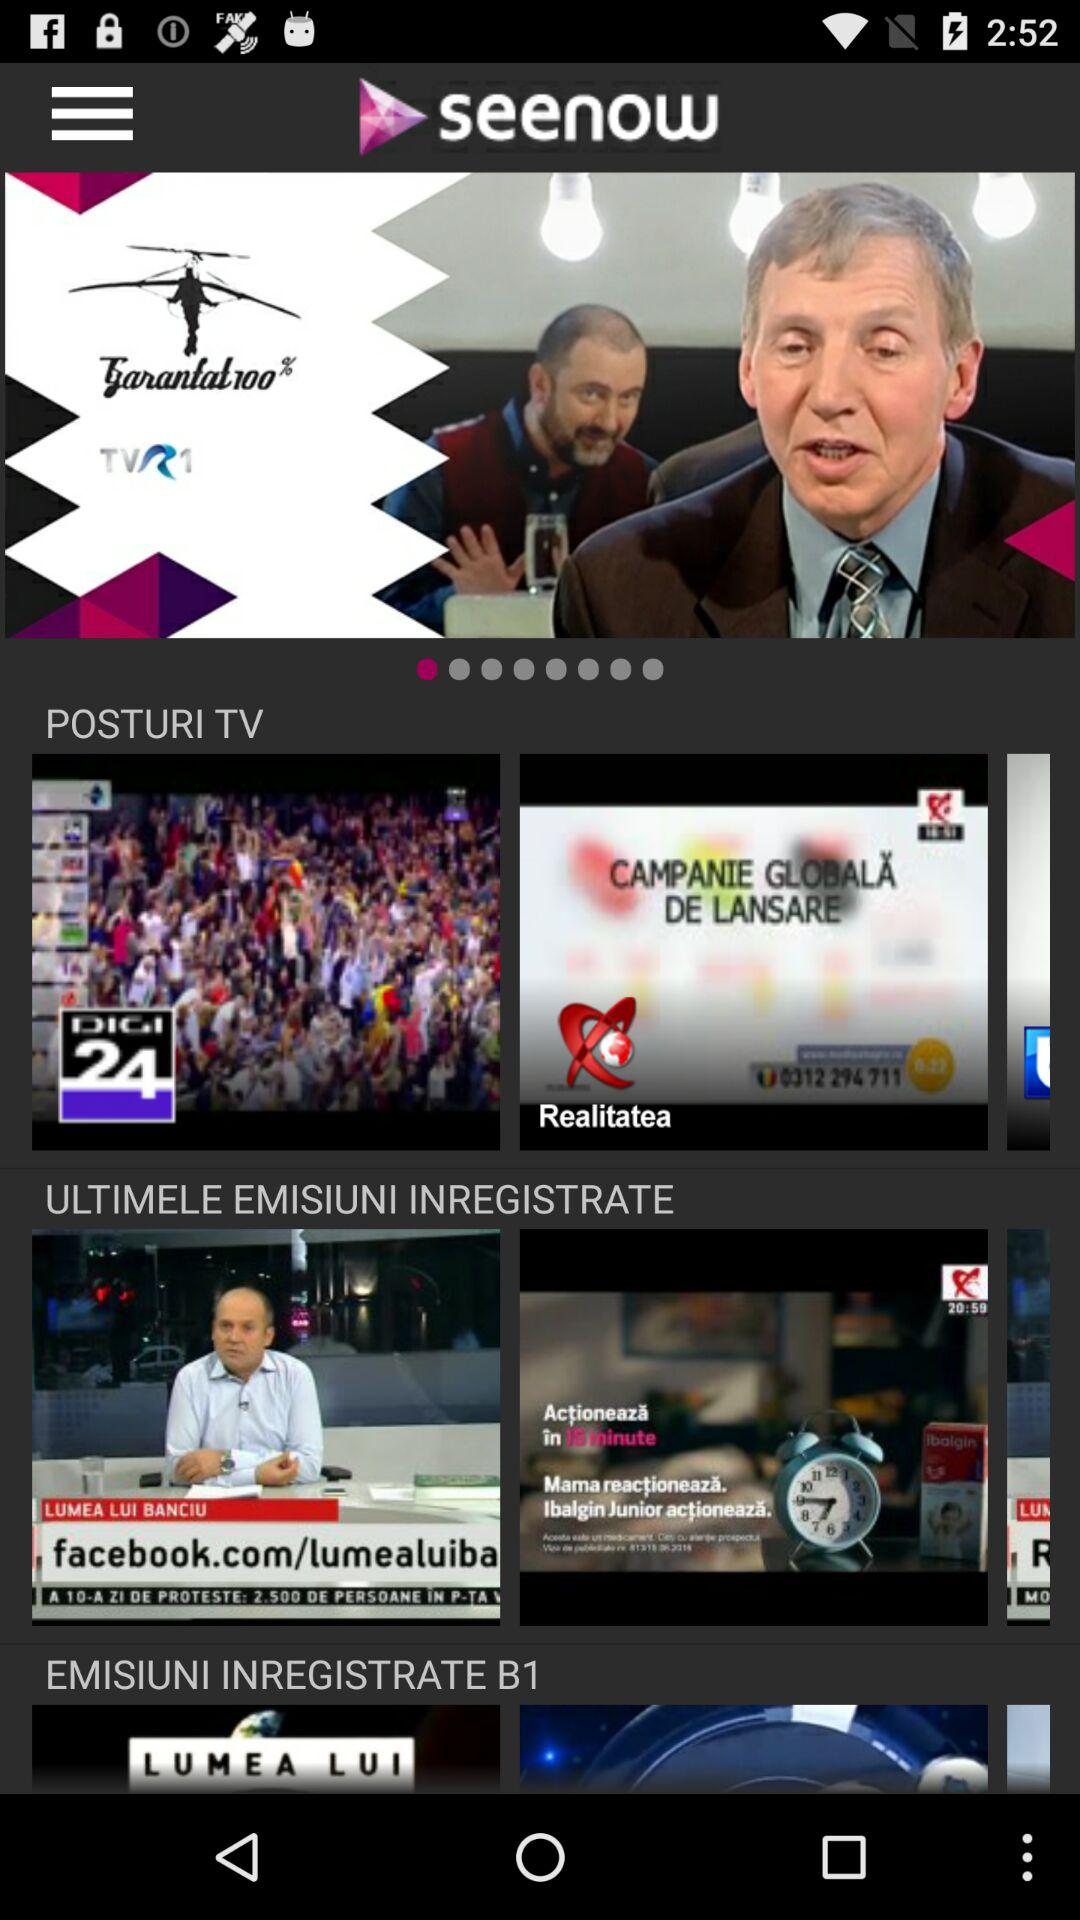How long is the duration of "Realitatea"?
When the provided information is insufficient, respond with <no answer>. <no answer> 